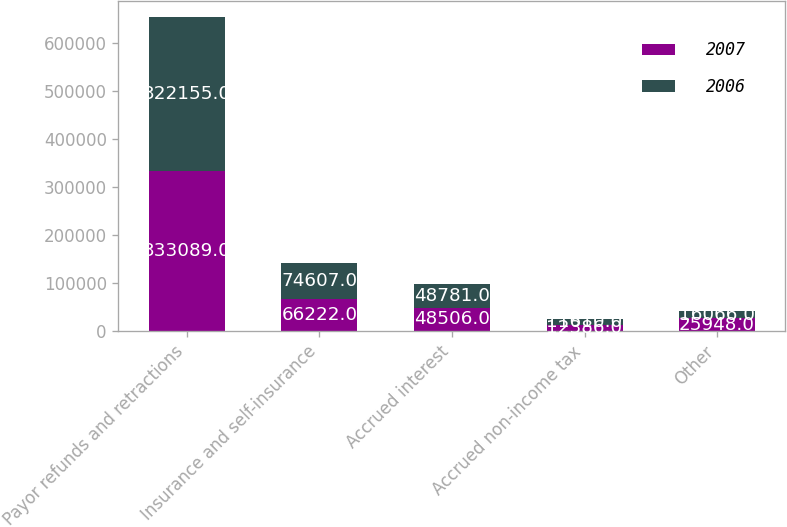Convert chart to OTSL. <chart><loc_0><loc_0><loc_500><loc_500><stacked_bar_chart><ecel><fcel>Payor refunds and retractions<fcel>Insurance and self-insurance<fcel>Accrued interest<fcel>Accrued non-income tax<fcel>Other<nl><fcel>2007<fcel>333089<fcel>66222<fcel>48506<fcel>12386<fcel>25948<nl><fcel>2006<fcel>322155<fcel>74607<fcel>48781<fcel>11610<fcel>16066<nl></chart> 